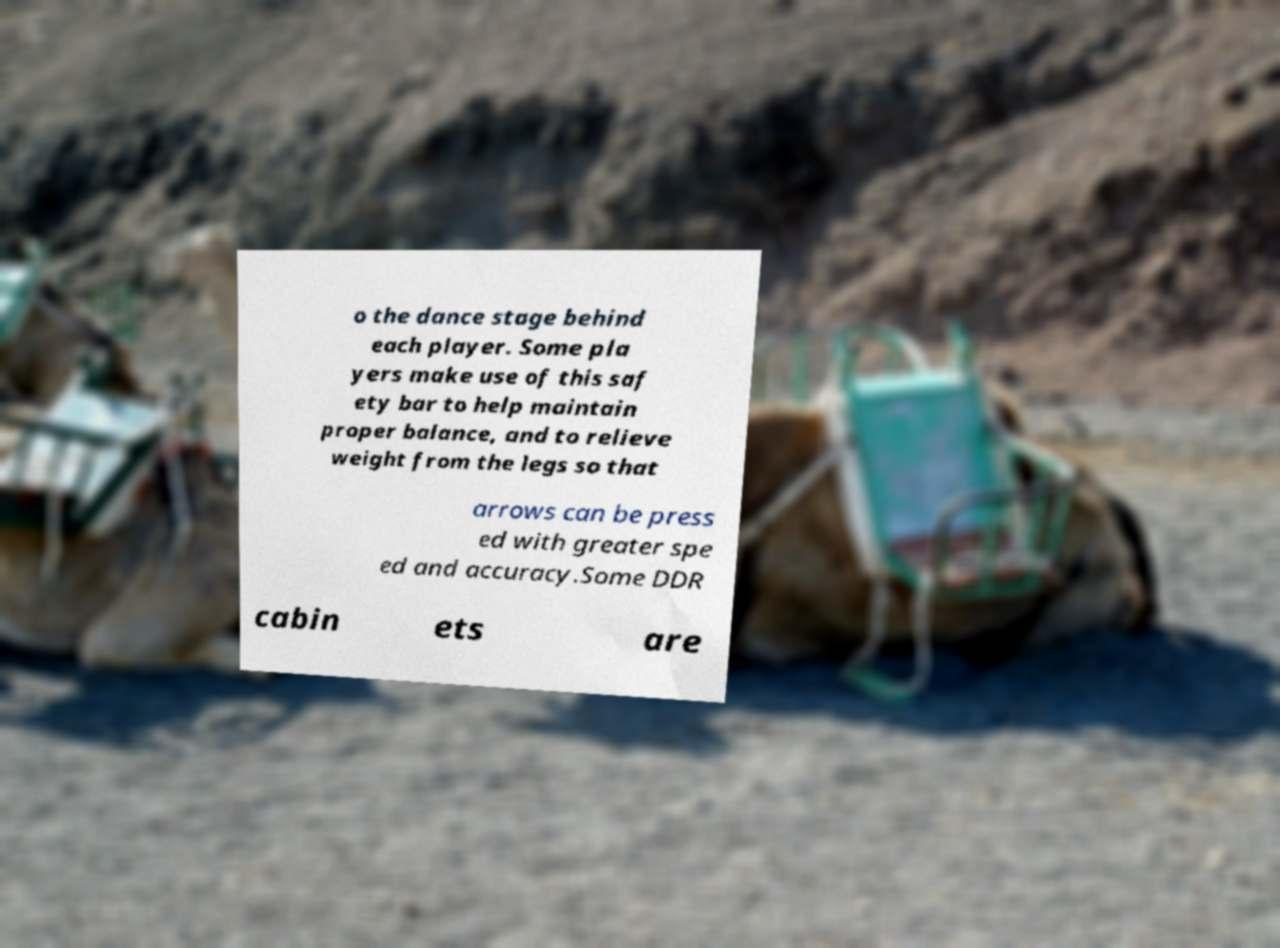Please read and relay the text visible in this image. What does it say? o the dance stage behind each player. Some pla yers make use of this saf ety bar to help maintain proper balance, and to relieve weight from the legs so that arrows can be press ed with greater spe ed and accuracy.Some DDR cabin ets are 